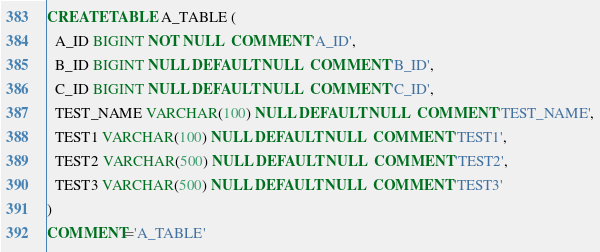<code> <loc_0><loc_0><loc_500><loc_500><_SQL_>CREATE TABLE A_TABLE (
  A_ID BIGINT NOT NULL  COMMENT 'A_ID',
  B_ID BIGINT NULL DEFAULT NULL  COMMENT 'B_ID',
  C_ID BIGINT NULL DEFAULT NULL  COMMENT 'C_ID',
  TEST_NAME VARCHAR(100) NULL DEFAULT NULL  COMMENT 'TEST_NAME',
  TEST1 VARCHAR(100) NULL DEFAULT NULL  COMMENT 'TEST1',
  TEST2 VARCHAR(500) NULL DEFAULT NULL  COMMENT 'TEST2',
  TEST3 VARCHAR(500) NULL DEFAULT NULL  COMMENT 'TEST3'
)
COMMENT='A_TABLE'</code> 